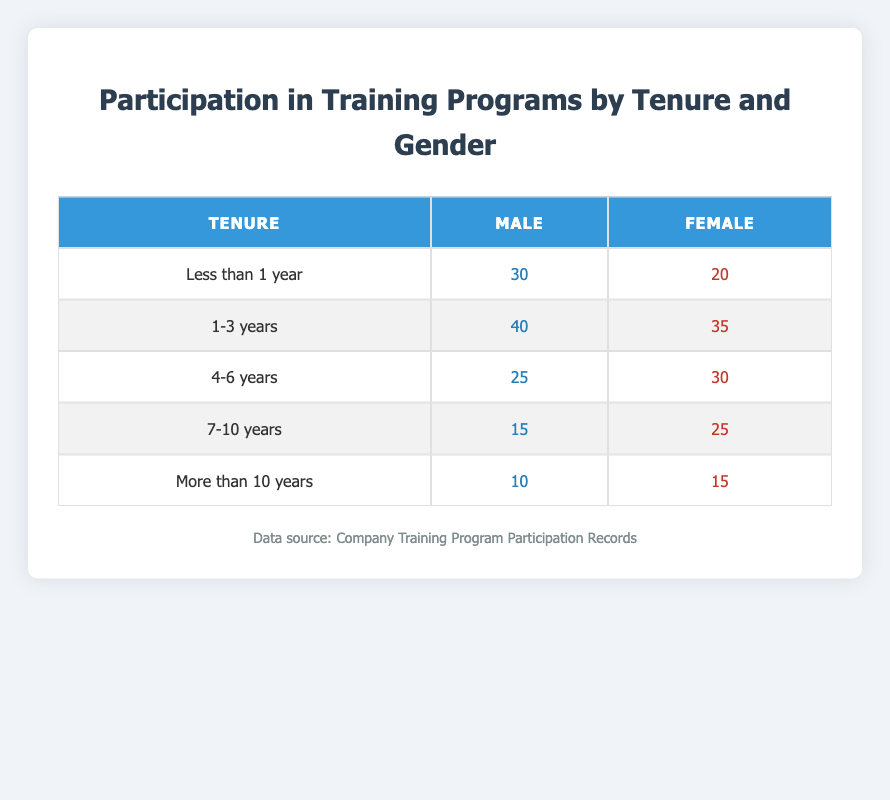What is the number of male participants with less than 1 year of tenure? The table shows that under the category "Less than 1 year" for gender "Male," the number of participants is listed as 30.
Answer: 30 What is the total number of female participants across all tenure categories? To find the total number of female participants, we add the participants from each tenure category: 20 (less than 1 year) + 35 (1-3 years) + 30 (4-6 years) + 25 (7-10 years) + 15 (more than 10 years) = 135.
Answer: 135 Is there a higher number of male participants in the "4-6 years" category compared to female participants? In the "4-6 years" category, the number of male participants is 25, while female participants are 30. Since 25 is less than 30, we conclude that the number of male participants is not higher.
Answer: No What is the average number of participants for male across all tenure categories? To find the average, we first sum the male participants: 30 (less than 1 year) + 40 (1-3 years) + 25 (4-6 years) + 15 (7-10 years) + 10 (more than 10 years) = 120. There are 5 tenure categories, so we divide 120 by 5, giving an average of 24.
Answer: 24 How many more participants are female than male in the "7-10 years" category? In the "7-10 years" category, there are 25 female participants and 15 male participants. To find out how many more female participants there are, we subtract the male participants from the female participants: 25 - 15 = 10.
Answer: 10 What is the percentage of male participants in the "1-3 years" tenure category compared to the total number of participants in that category? In the "1-3 years" category, there are 40 male and 35 female participants, making the total 75. The percentage of male participants is calculated as (40 / 75) * 100, which equals approximately 53.33%.
Answer: 53.33% Does the number of female participants decrease as tenure increases? Comparing categories, we see that female participants count is: 20 (less than 1 year), 35 (1-3 years), 30 (4-6 years), 25 (7-10 years), and 15 (more than 10 years). This shows a decrease from 35 to 30, then to 25 and to 15, confirming a decrease overall.
Answer: Yes 